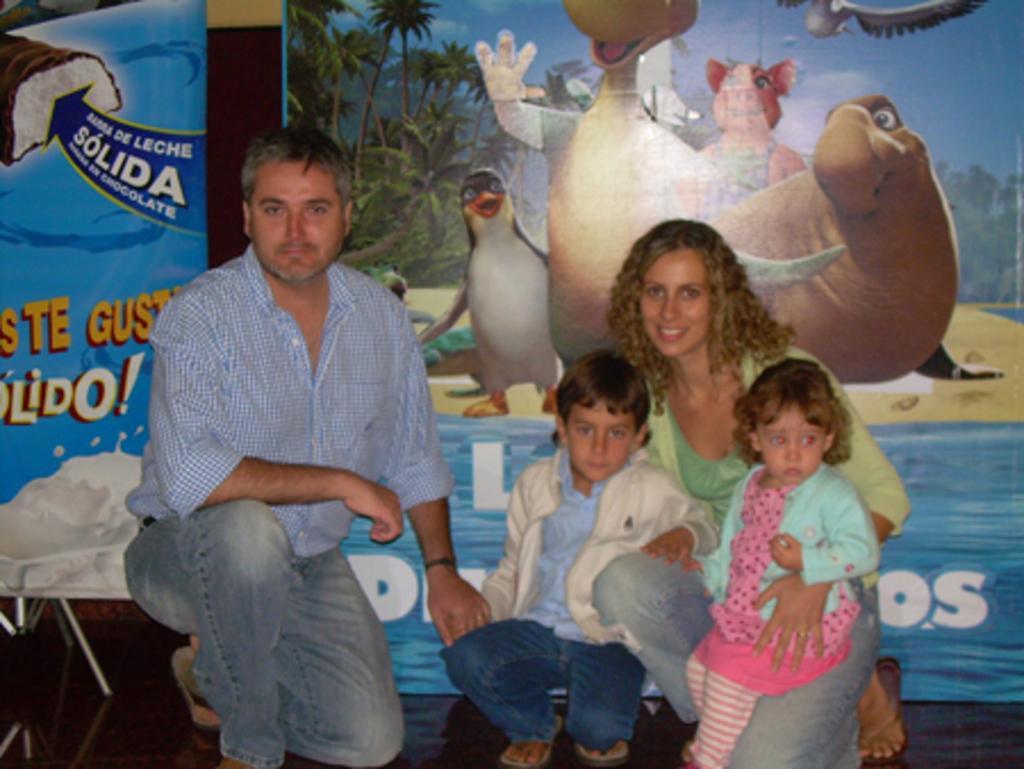Please provide a concise description of this image. In this image I can see four people with different color dresses. In the back I can see the banners. In the banners I can see the animals, trees and the sky. To the left I can see the blue color banner and something is written on it. 